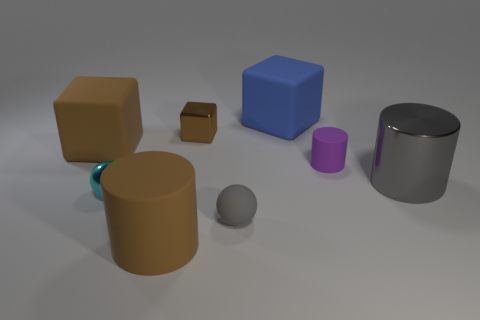Do the metallic cube and the large matte cylinder have the same color?
Your response must be concise. Yes. Are there any large shiny things that have the same color as the rubber sphere?
Your answer should be compact. Yes. How many metal objects are either large brown things or blocks?
Make the answer very short. 1. What number of blue matte blocks are in front of the matte cube that is to the left of the brown metal block?
Offer a terse response. 0. How many big blue objects are the same material as the cyan sphere?
Your response must be concise. 0. How many tiny things are either purple rubber objects or brown metallic blocks?
Your response must be concise. 2. What shape is the large rubber thing that is to the right of the tiny cyan shiny thing and behind the small cylinder?
Provide a succinct answer. Cube. Do the big gray object and the big blue cube have the same material?
Your response must be concise. No. The matte cylinder that is the same size as the gray rubber object is what color?
Give a very brief answer. Purple. What color is the thing that is both in front of the cyan thing and behind the big brown cylinder?
Provide a succinct answer. Gray. 